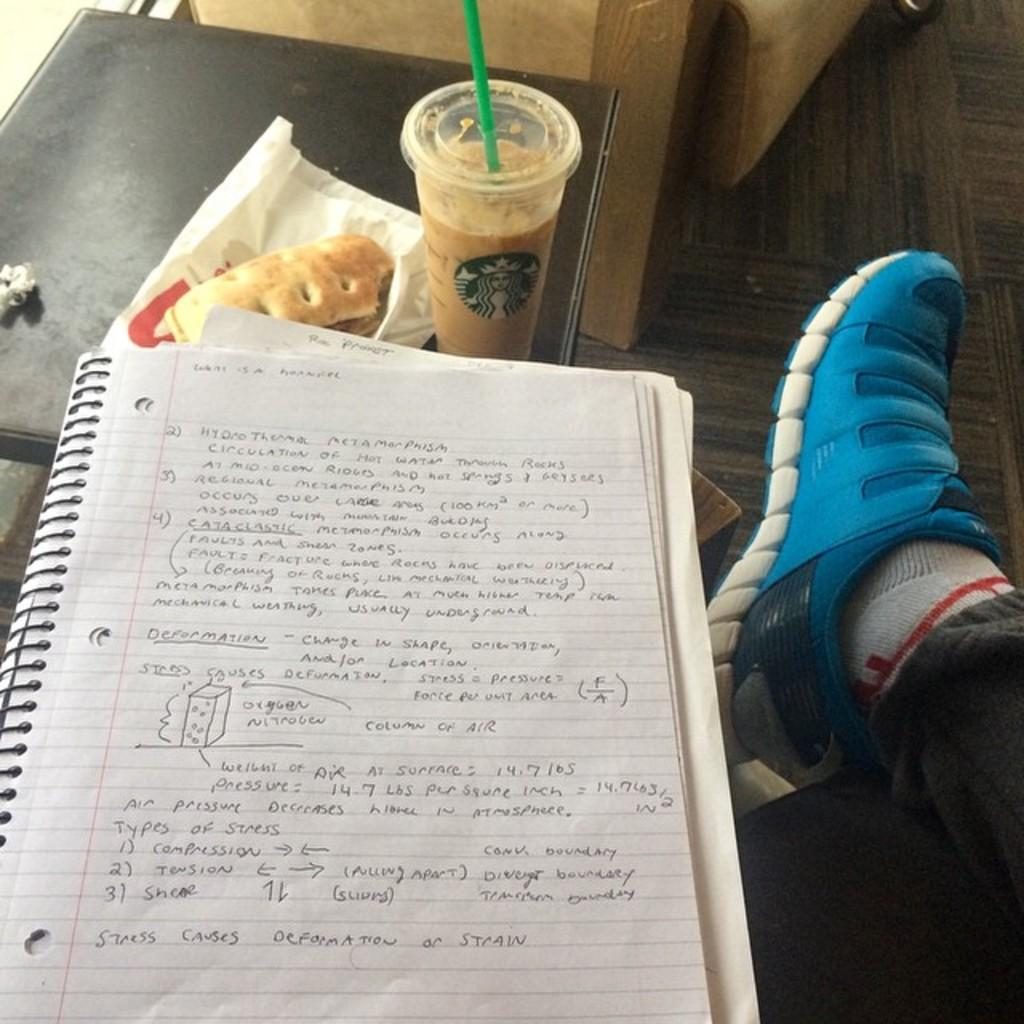What part of a person's body is visible in the image? There is a person's leg in the image. What object related to reading can be seen in the image? There is a book in the image. What type of food is present in the image? There is a sandwich in the image. What container is visible in the image? There is a glass tumbler in the image. What type of ladybug can be seen crawling on the sandwich in the image? There is no ladybug present in the image; it only features a sandwich, a book, a glass tumbler, and a person's leg. What kind of beast is offering the sandwich in the image? There is no beast present in the image, and the sandwich is not being offered by anyone or anything. 